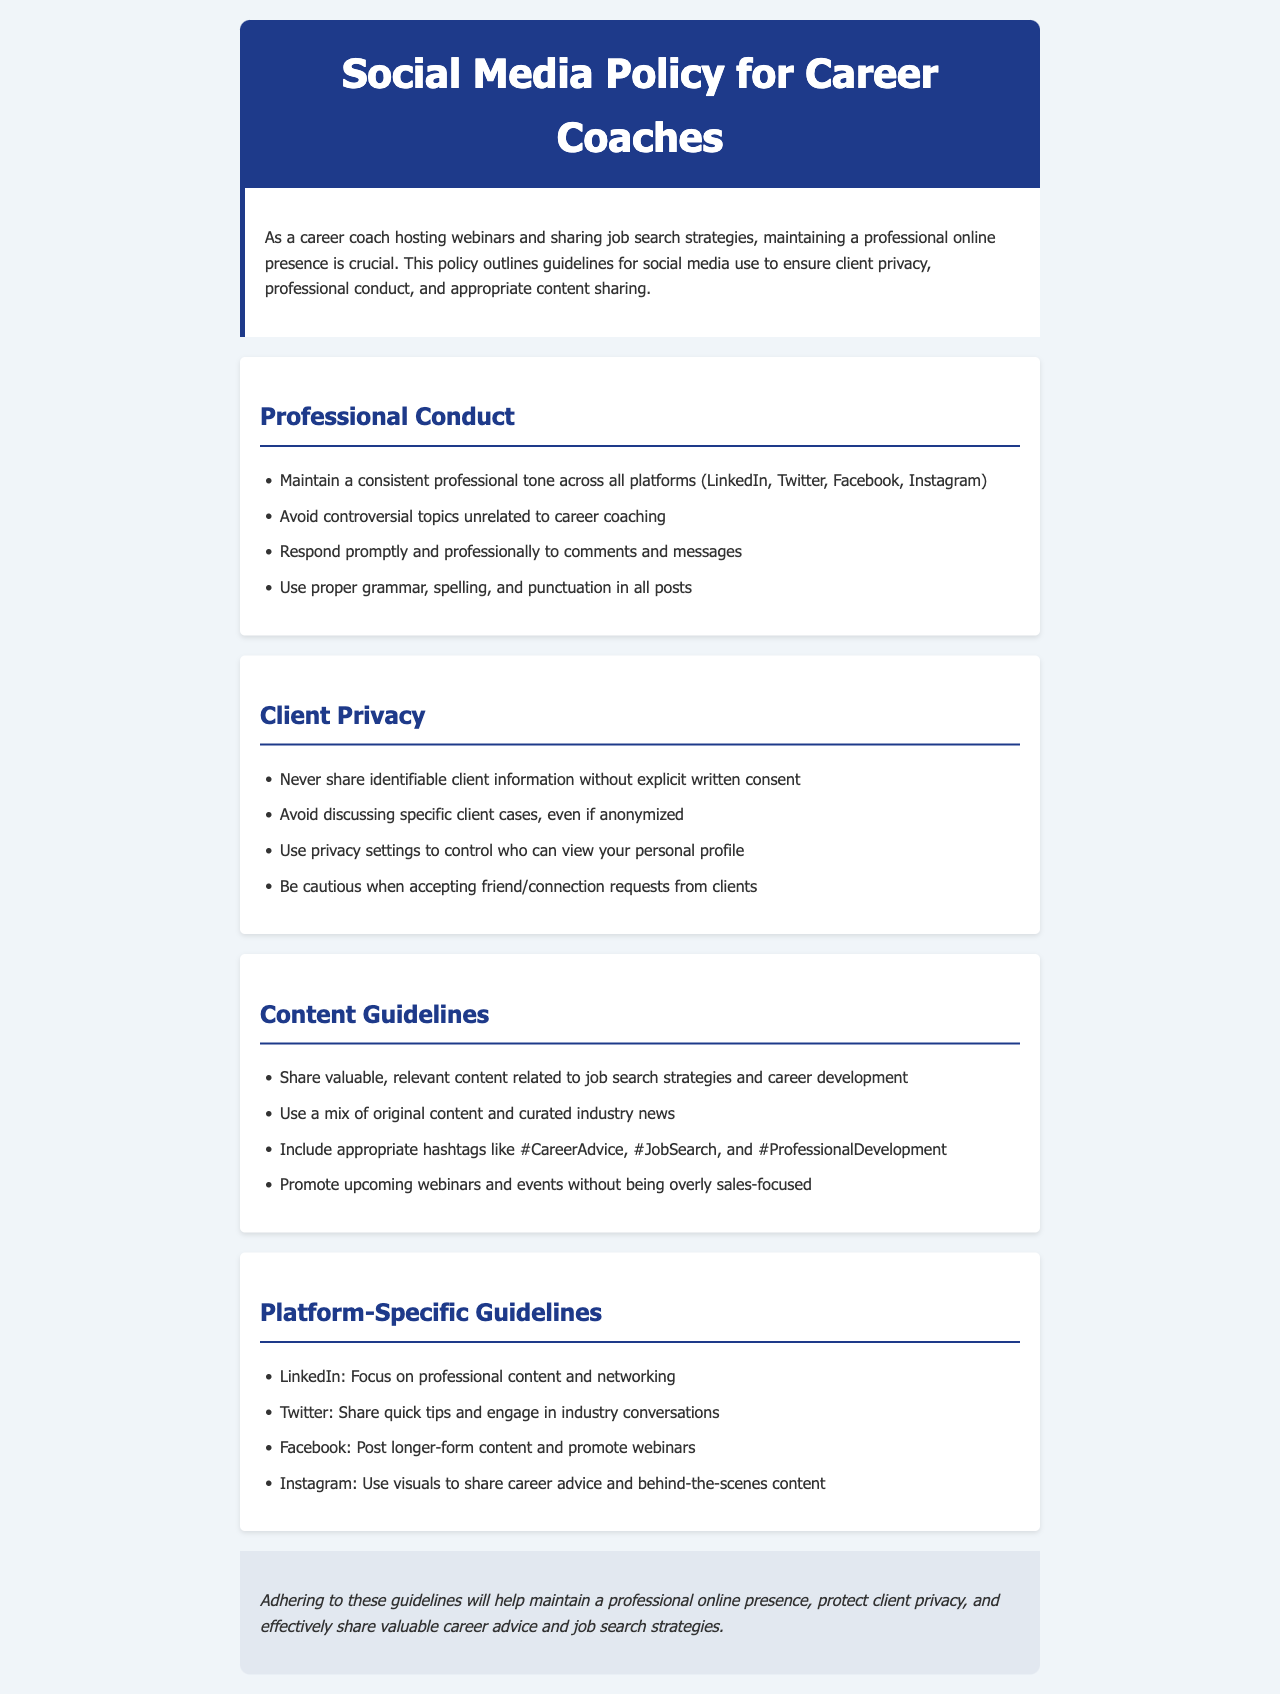What are the main areas outlined in the policy? The main areas outlined in the policy include Professional Conduct, Client Privacy, Content Guidelines, and Platform-Specific Guidelines.
Answer: Professional Conduct, Client Privacy, Content Guidelines, Platform-Specific Guidelines What should you never share without consent? The document explicitly states that you should never share identifiable client information without explicit written consent.
Answer: Identifiable client information Which social media platforms are mentioned? The platforms mentioned in the document are LinkedIn, Twitter, Facebook, and Instagram.
Answer: LinkedIn, Twitter, Facebook, Instagram What is the suggested approach to handling comments and messages? The document suggests responding promptly and professionally to comments and messages.
Answer: Promptly and professionally List one guideline regarding client privacy. One guideline regarding client privacy is to avoid discussing specific client cases, even if anonymized.
Answer: Avoid discussing specific client cases What type of content should be shared according to the Content Guidelines? According to the Content Guidelines, you should share valuable, relevant content related to job search strategies and career development.
Answer: Valuable, relevant content What is emphasized for LinkedIn usage? The document emphasizes focusing on professional content and networking for LinkedIn usage.
Answer: Professional content and networking How should personal profiles be managed? The document advises using privacy settings to control who can view your personal profile.
Answer: Use privacy settings What is the tone recommended for social media posts? The recommended tone for social media posts is a consistent professional tone across all platforms.
Answer: Consistent professional tone 